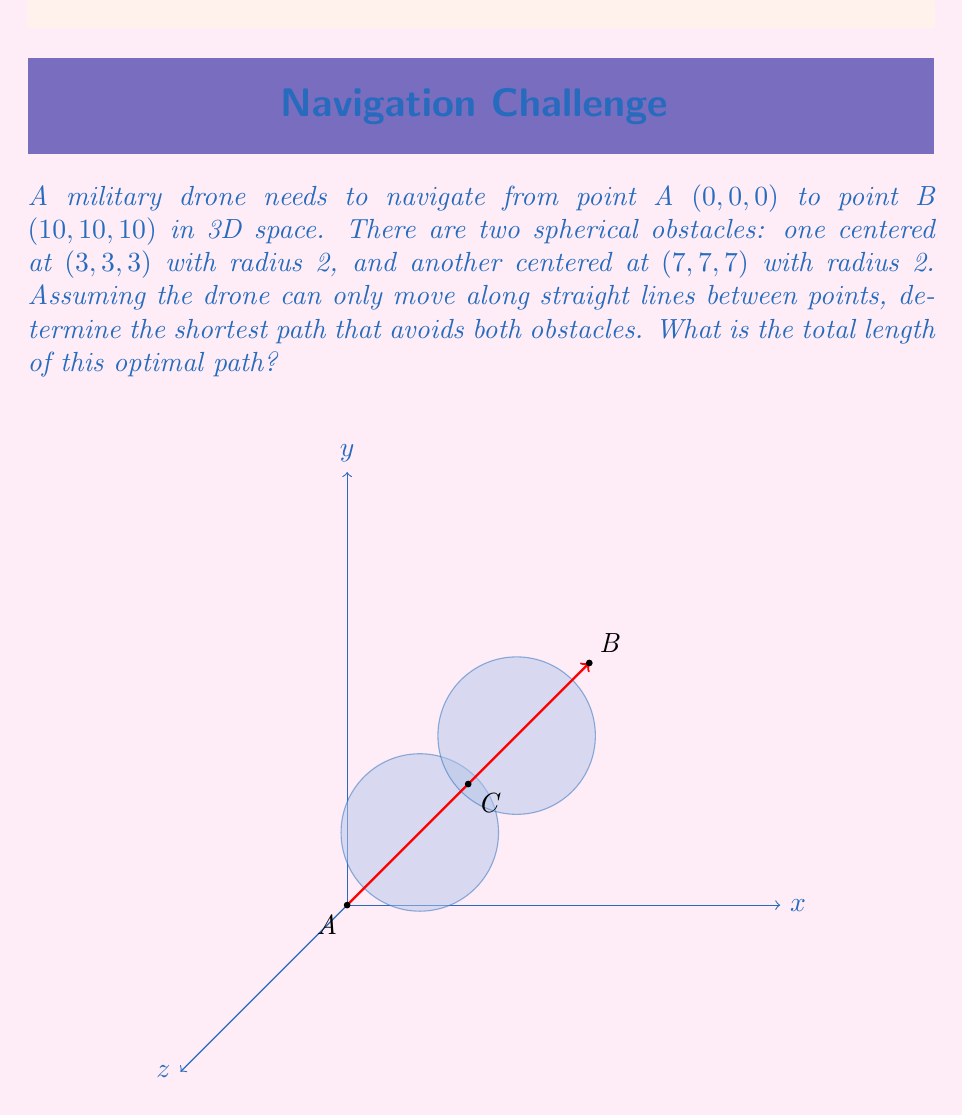Help me with this question. To solve this problem, we need to follow these steps:

1) First, we observe that the straight line from A to B passes through the centers of both obstacles. Therefore, we need to find an intermediate point C that allows us to avoid both obstacles while minimizing the total path length.

2) Due to the symmetry of the problem, we can deduce that the optimal point C will lie on the line segment AB, specifically at the midpoint (5, 5, 5).

3) Now, we need to calculate the length of the path A-C-B:

   Length AC = Length CB = $\sqrt{(5-0)^2 + (5-0)^2 + (5-0)^2} = 5\sqrt{3}$

4) The total path length is thus:

   $AC + CB = 5\sqrt{3} + 5\sqrt{3} = 10\sqrt{3}$

5) We need to verify that this path indeed avoids both obstacles. The distance from point C to the center of each obstacle is:

   $\sqrt{(5-3)^2 + (5-3)^2 + (5-3)^2} = \sqrt{12} = 2\sqrt{3}$

   This is greater than the radius of each obstacle (2), so the path is valid.

6) To confirm this is the optimal path, we can consider that any other path would require deviating further from the straight line AB, thus increasing the total length.

Therefore, the optimal flight path for the drone is from A to C to B, with C at (5, 5, 5), and the total length of this path is $10\sqrt{3}$.
Answer: $10\sqrt{3}$ 